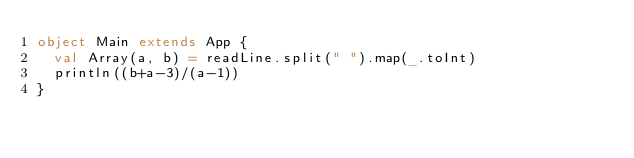<code> <loc_0><loc_0><loc_500><loc_500><_Scala_>object Main extends App {
  val Array(a, b) = readLine.split(" ").map(_.toInt)
  println((b+a-3)/(a-1))
}</code> 